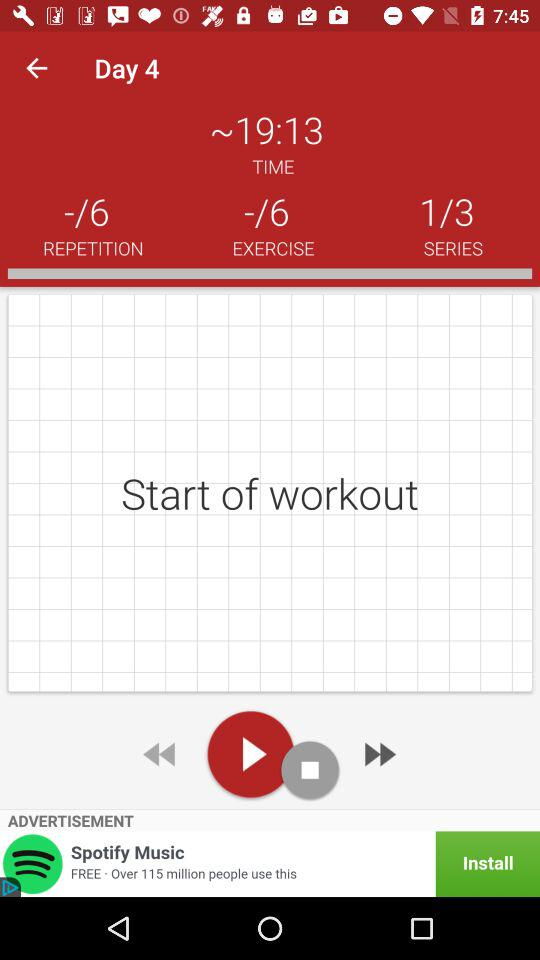What is the duration of the workout?
When the provided information is insufficient, respond with <no answer>. <no answer> 